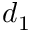Convert formula to latex. <formula><loc_0><loc_0><loc_500><loc_500>d _ { 1 }</formula> 